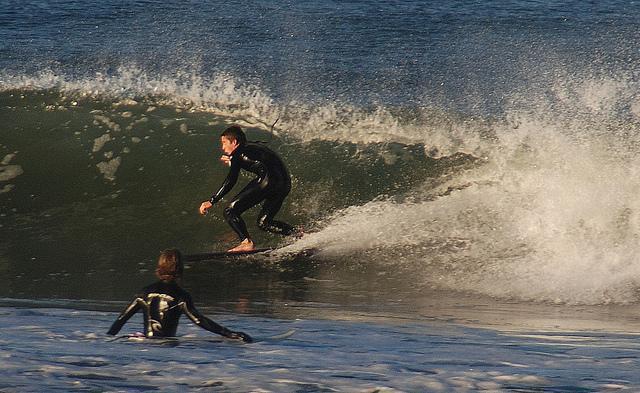Why is the man in black crouched?
Choose the right answer from the provided options to respond to the question.
Options: To dive, to jump, gain speed, to sit. Gain speed. 